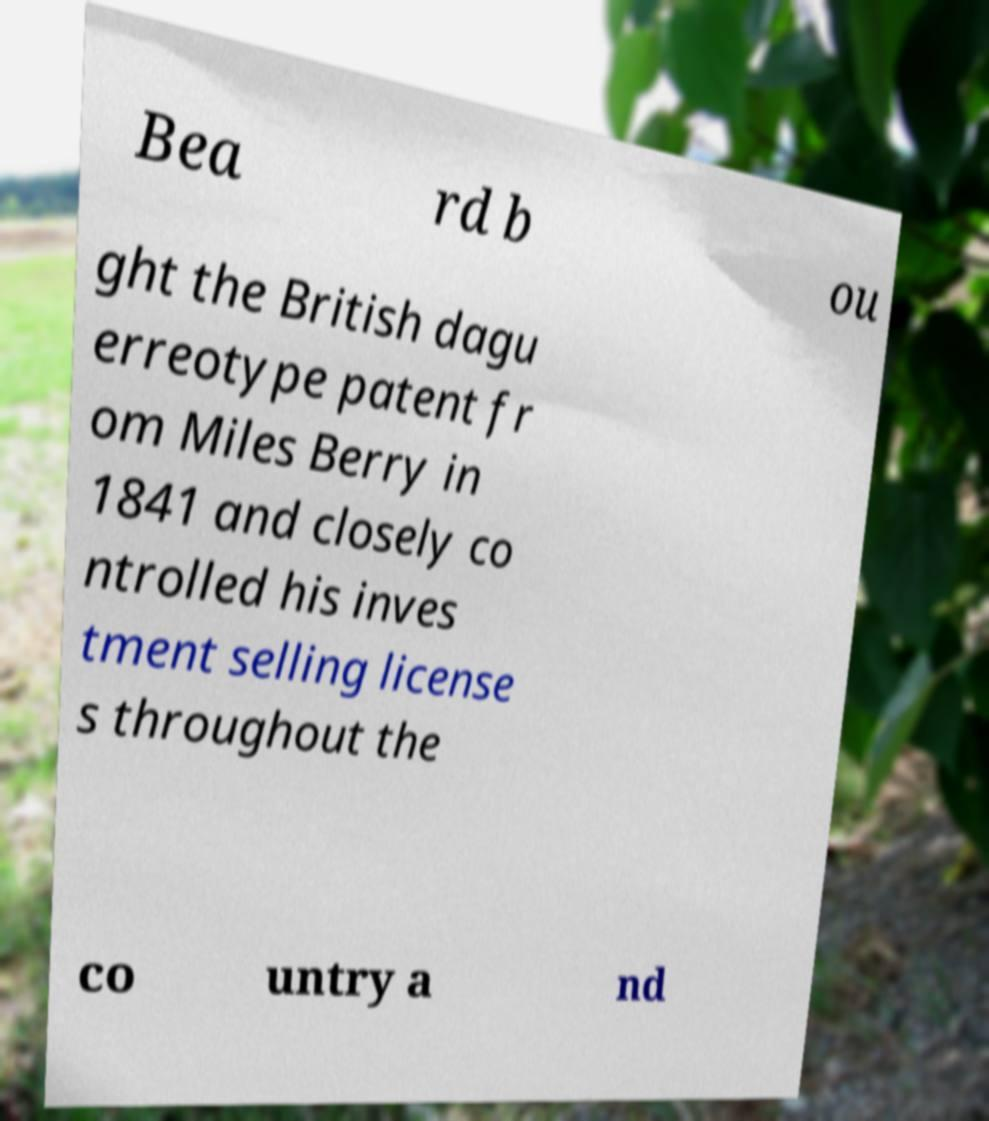Could you assist in decoding the text presented in this image and type it out clearly? Bea rd b ou ght the British dagu erreotype patent fr om Miles Berry in 1841 and closely co ntrolled his inves tment selling license s throughout the co untry a nd 